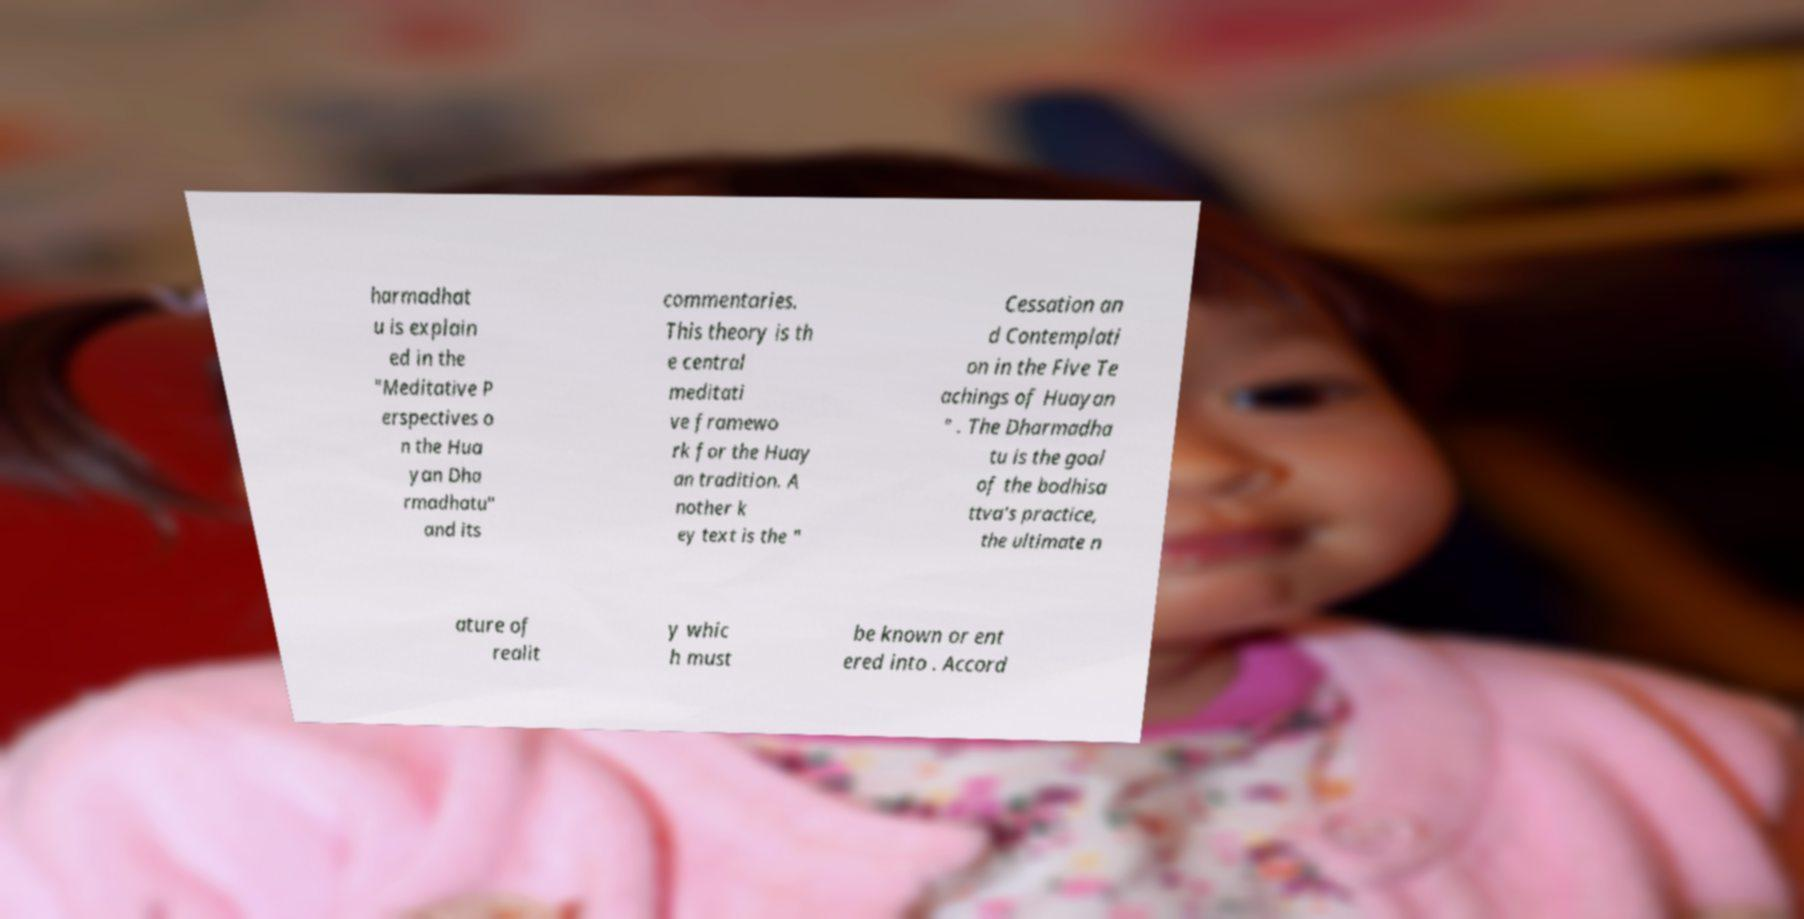Please identify and transcribe the text found in this image. harmadhat u is explain ed in the "Meditative P erspectives o n the Hua yan Dha rmadhatu" and its commentaries. This theory is th e central meditati ve framewo rk for the Huay an tradition. A nother k ey text is the " Cessation an d Contemplati on in the Five Te achings of Huayan " . The Dharmadha tu is the goal of the bodhisa ttva's practice, the ultimate n ature of realit y whic h must be known or ent ered into . Accord 